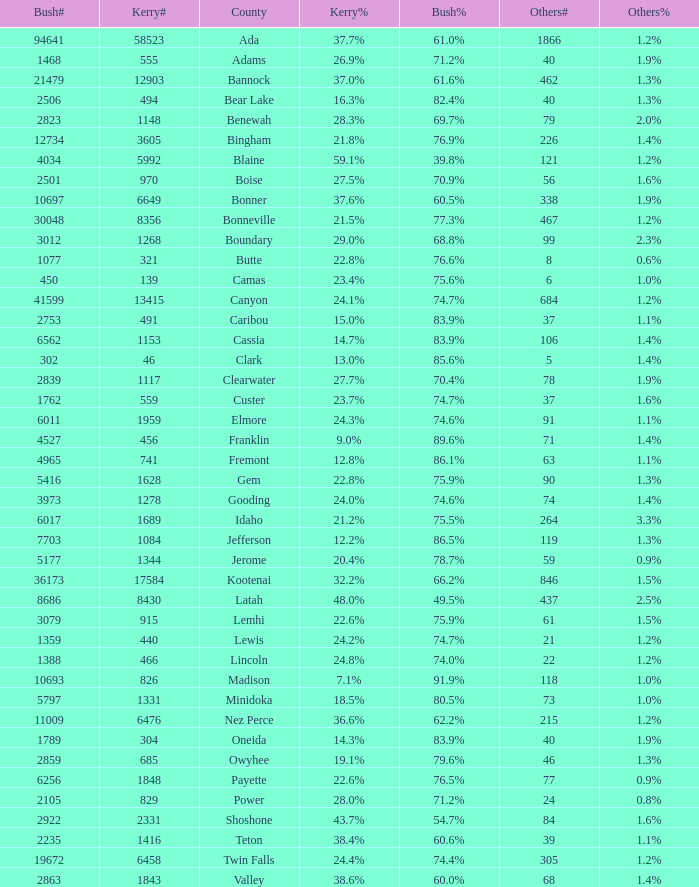What percentage of the votes were for others in the county where 462 people voted that way? 1.3%. 